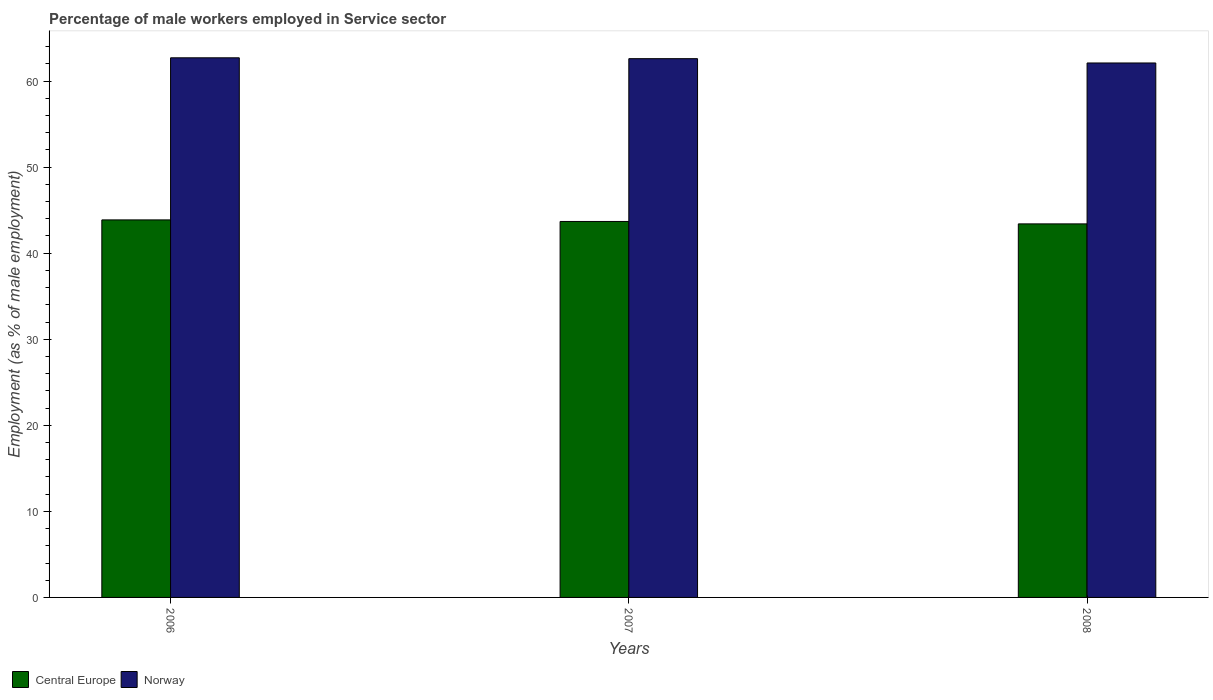How many different coloured bars are there?
Your answer should be compact. 2. Are the number of bars per tick equal to the number of legend labels?
Your answer should be compact. Yes. Are the number of bars on each tick of the X-axis equal?
Offer a terse response. Yes. How many bars are there on the 2nd tick from the right?
Provide a succinct answer. 2. What is the label of the 2nd group of bars from the left?
Make the answer very short. 2007. In how many cases, is the number of bars for a given year not equal to the number of legend labels?
Keep it short and to the point. 0. What is the percentage of male workers employed in Service sector in Norway in 2008?
Make the answer very short. 62.1. Across all years, what is the maximum percentage of male workers employed in Service sector in Central Europe?
Offer a very short reply. 43.87. Across all years, what is the minimum percentage of male workers employed in Service sector in Central Europe?
Provide a succinct answer. 43.4. In which year was the percentage of male workers employed in Service sector in Norway maximum?
Ensure brevity in your answer.  2006. In which year was the percentage of male workers employed in Service sector in Norway minimum?
Provide a short and direct response. 2008. What is the total percentage of male workers employed in Service sector in Norway in the graph?
Your answer should be compact. 187.4. What is the difference between the percentage of male workers employed in Service sector in Norway in 2006 and that in 2007?
Make the answer very short. 0.1. What is the difference between the percentage of male workers employed in Service sector in Norway in 2007 and the percentage of male workers employed in Service sector in Central Europe in 2006?
Give a very brief answer. 18.73. What is the average percentage of male workers employed in Service sector in Norway per year?
Provide a succinct answer. 62.47. In the year 2008, what is the difference between the percentage of male workers employed in Service sector in Central Europe and percentage of male workers employed in Service sector in Norway?
Make the answer very short. -18.7. What is the ratio of the percentage of male workers employed in Service sector in Norway in 2006 to that in 2007?
Offer a terse response. 1. Is the difference between the percentage of male workers employed in Service sector in Central Europe in 2007 and 2008 greater than the difference between the percentage of male workers employed in Service sector in Norway in 2007 and 2008?
Your answer should be very brief. No. What is the difference between the highest and the second highest percentage of male workers employed in Service sector in Central Europe?
Keep it short and to the point. 0.18. What is the difference between the highest and the lowest percentage of male workers employed in Service sector in Norway?
Ensure brevity in your answer.  0.6. In how many years, is the percentage of male workers employed in Service sector in Central Europe greater than the average percentage of male workers employed in Service sector in Central Europe taken over all years?
Keep it short and to the point. 2. What does the 2nd bar from the right in 2007 represents?
Your answer should be compact. Central Europe. What is the difference between two consecutive major ticks on the Y-axis?
Keep it short and to the point. 10. Does the graph contain any zero values?
Offer a terse response. No. Does the graph contain grids?
Give a very brief answer. No. Where does the legend appear in the graph?
Keep it short and to the point. Bottom left. How many legend labels are there?
Offer a terse response. 2. What is the title of the graph?
Keep it short and to the point. Percentage of male workers employed in Service sector. What is the label or title of the X-axis?
Keep it short and to the point. Years. What is the label or title of the Y-axis?
Offer a very short reply. Employment (as % of male employment). What is the Employment (as % of male employment) of Central Europe in 2006?
Ensure brevity in your answer.  43.87. What is the Employment (as % of male employment) of Norway in 2006?
Keep it short and to the point. 62.7. What is the Employment (as % of male employment) of Central Europe in 2007?
Provide a succinct answer. 43.68. What is the Employment (as % of male employment) of Norway in 2007?
Give a very brief answer. 62.6. What is the Employment (as % of male employment) in Central Europe in 2008?
Your response must be concise. 43.4. What is the Employment (as % of male employment) in Norway in 2008?
Your answer should be compact. 62.1. Across all years, what is the maximum Employment (as % of male employment) of Central Europe?
Give a very brief answer. 43.87. Across all years, what is the maximum Employment (as % of male employment) of Norway?
Your answer should be compact. 62.7. Across all years, what is the minimum Employment (as % of male employment) of Central Europe?
Provide a succinct answer. 43.4. Across all years, what is the minimum Employment (as % of male employment) in Norway?
Your response must be concise. 62.1. What is the total Employment (as % of male employment) of Central Europe in the graph?
Offer a terse response. 130.95. What is the total Employment (as % of male employment) in Norway in the graph?
Offer a terse response. 187.4. What is the difference between the Employment (as % of male employment) in Central Europe in 2006 and that in 2007?
Give a very brief answer. 0.18. What is the difference between the Employment (as % of male employment) of Norway in 2006 and that in 2007?
Give a very brief answer. 0.1. What is the difference between the Employment (as % of male employment) of Central Europe in 2006 and that in 2008?
Keep it short and to the point. 0.46. What is the difference between the Employment (as % of male employment) of Norway in 2006 and that in 2008?
Give a very brief answer. 0.6. What is the difference between the Employment (as % of male employment) in Central Europe in 2007 and that in 2008?
Provide a short and direct response. 0.28. What is the difference between the Employment (as % of male employment) of Norway in 2007 and that in 2008?
Give a very brief answer. 0.5. What is the difference between the Employment (as % of male employment) of Central Europe in 2006 and the Employment (as % of male employment) of Norway in 2007?
Keep it short and to the point. -18.73. What is the difference between the Employment (as % of male employment) of Central Europe in 2006 and the Employment (as % of male employment) of Norway in 2008?
Give a very brief answer. -18.23. What is the difference between the Employment (as % of male employment) of Central Europe in 2007 and the Employment (as % of male employment) of Norway in 2008?
Provide a succinct answer. -18.42. What is the average Employment (as % of male employment) in Central Europe per year?
Give a very brief answer. 43.65. What is the average Employment (as % of male employment) in Norway per year?
Your response must be concise. 62.47. In the year 2006, what is the difference between the Employment (as % of male employment) of Central Europe and Employment (as % of male employment) of Norway?
Provide a succinct answer. -18.83. In the year 2007, what is the difference between the Employment (as % of male employment) of Central Europe and Employment (as % of male employment) of Norway?
Give a very brief answer. -18.92. In the year 2008, what is the difference between the Employment (as % of male employment) of Central Europe and Employment (as % of male employment) of Norway?
Give a very brief answer. -18.7. What is the ratio of the Employment (as % of male employment) of Central Europe in 2006 to that in 2007?
Provide a short and direct response. 1. What is the ratio of the Employment (as % of male employment) of Central Europe in 2006 to that in 2008?
Give a very brief answer. 1.01. What is the ratio of the Employment (as % of male employment) in Norway in 2006 to that in 2008?
Your response must be concise. 1.01. What is the difference between the highest and the second highest Employment (as % of male employment) in Central Europe?
Your response must be concise. 0.18. What is the difference between the highest and the second highest Employment (as % of male employment) in Norway?
Ensure brevity in your answer.  0.1. What is the difference between the highest and the lowest Employment (as % of male employment) in Central Europe?
Make the answer very short. 0.46. 